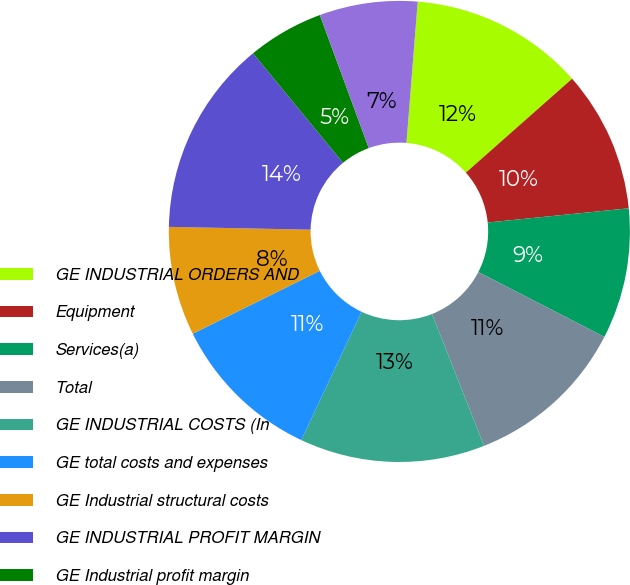Convert chart to OTSL. <chart><loc_0><loc_0><loc_500><loc_500><pie_chart><fcel>GE INDUSTRIAL ORDERS AND<fcel>Equipment<fcel>Services(a)<fcel>Total<fcel>GE INDUSTRIAL COSTS (In<fcel>GE total costs and expenses<fcel>GE Industrial structural costs<fcel>GE INDUSTRIAL PROFIT MARGIN<fcel>GE Industrial profit margin<fcel>Adjusted GE Industrial profit<nl><fcel>12.21%<fcel>9.92%<fcel>9.16%<fcel>11.45%<fcel>12.98%<fcel>10.69%<fcel>7.63%<fcel>13.74%<fcel>5.34%<fcel>6.87%<nl></chart> 